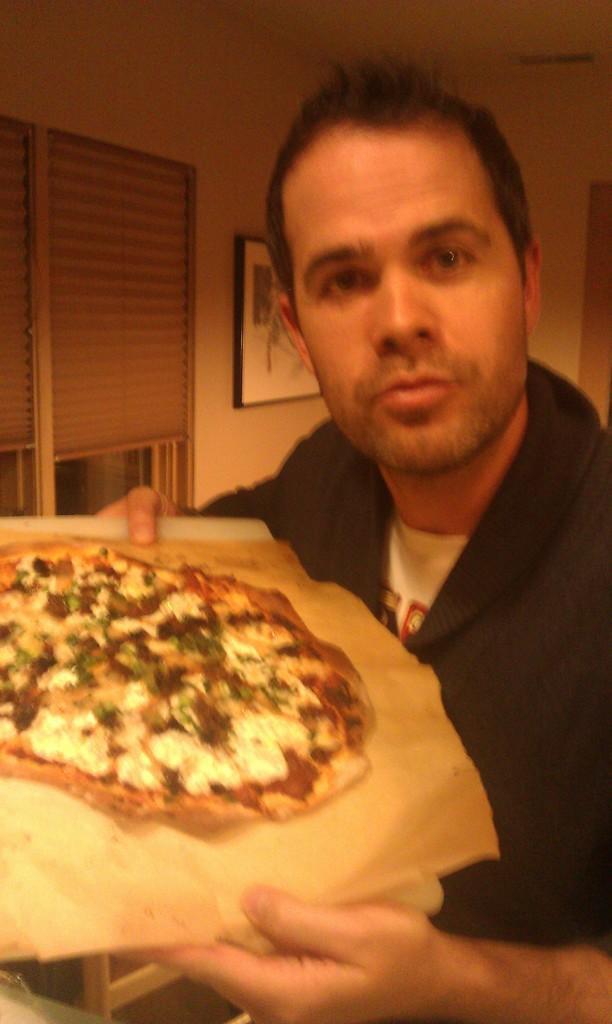In one or two sentences, can you explain what this image depicts? In this image I can see a person holding a plate with food item on it. There are walls and there is a photo frame attached to one of the wall. In the top left corner of the image it looks like a window. 